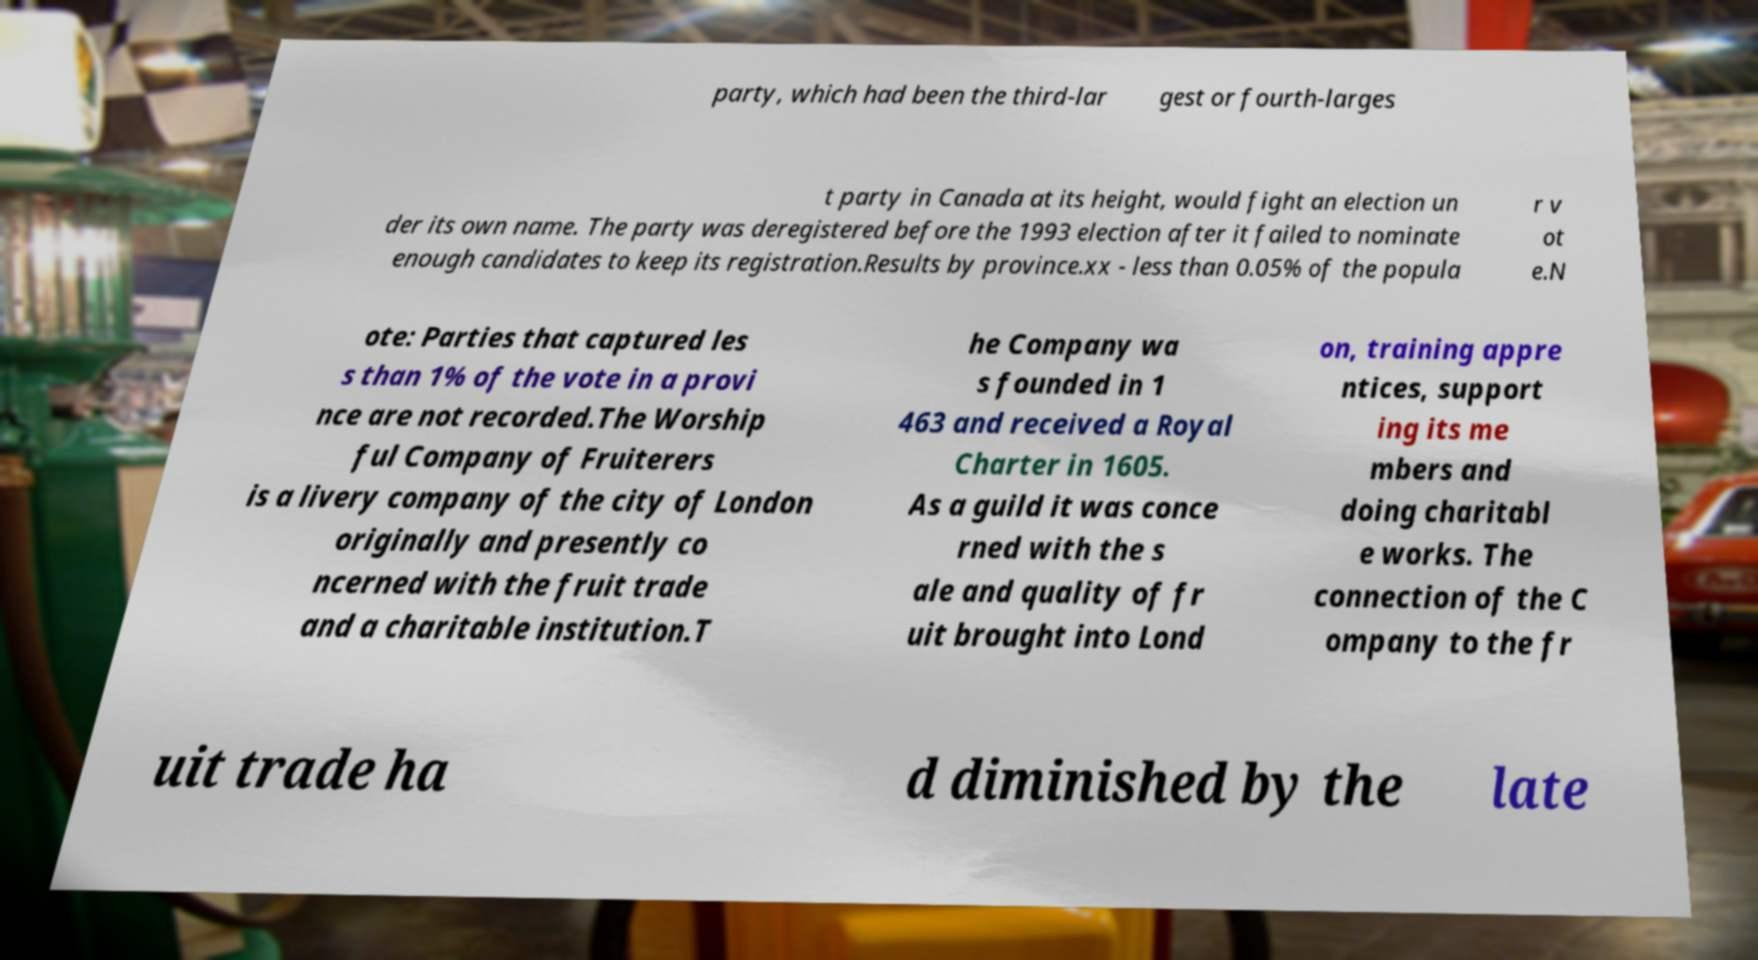There's text embedded in this image that I need extracted. Can you transcribe it verbatim? party, which had been the third-lar gest or fourth-larges t party in Canada at its height, would fight an election un der its own name. The party was deregistered before the 1993 election after it failed to nominate enough candidates to keep its registration.Results by province.xx - less than 0.05% of the popula r v ot e.N ote: Parties that captured les s than 1% of the vote in a provi nce are not recorded.The Worship ful Company of Fruiterers is a livery company of the city of London originally and presently co ncerned with the fruit trade and a charitable institution.T he Company wa s founded in 1 463 and received a Royal Charter in 1605. As a guild it was conce rned with the s ale and quality of fr uit brought into Lond on, training appre ntices, support ing its me mbers and doing charitabl e works. The connection of the C ompany to the fr uit trade ha d diminished by the late 